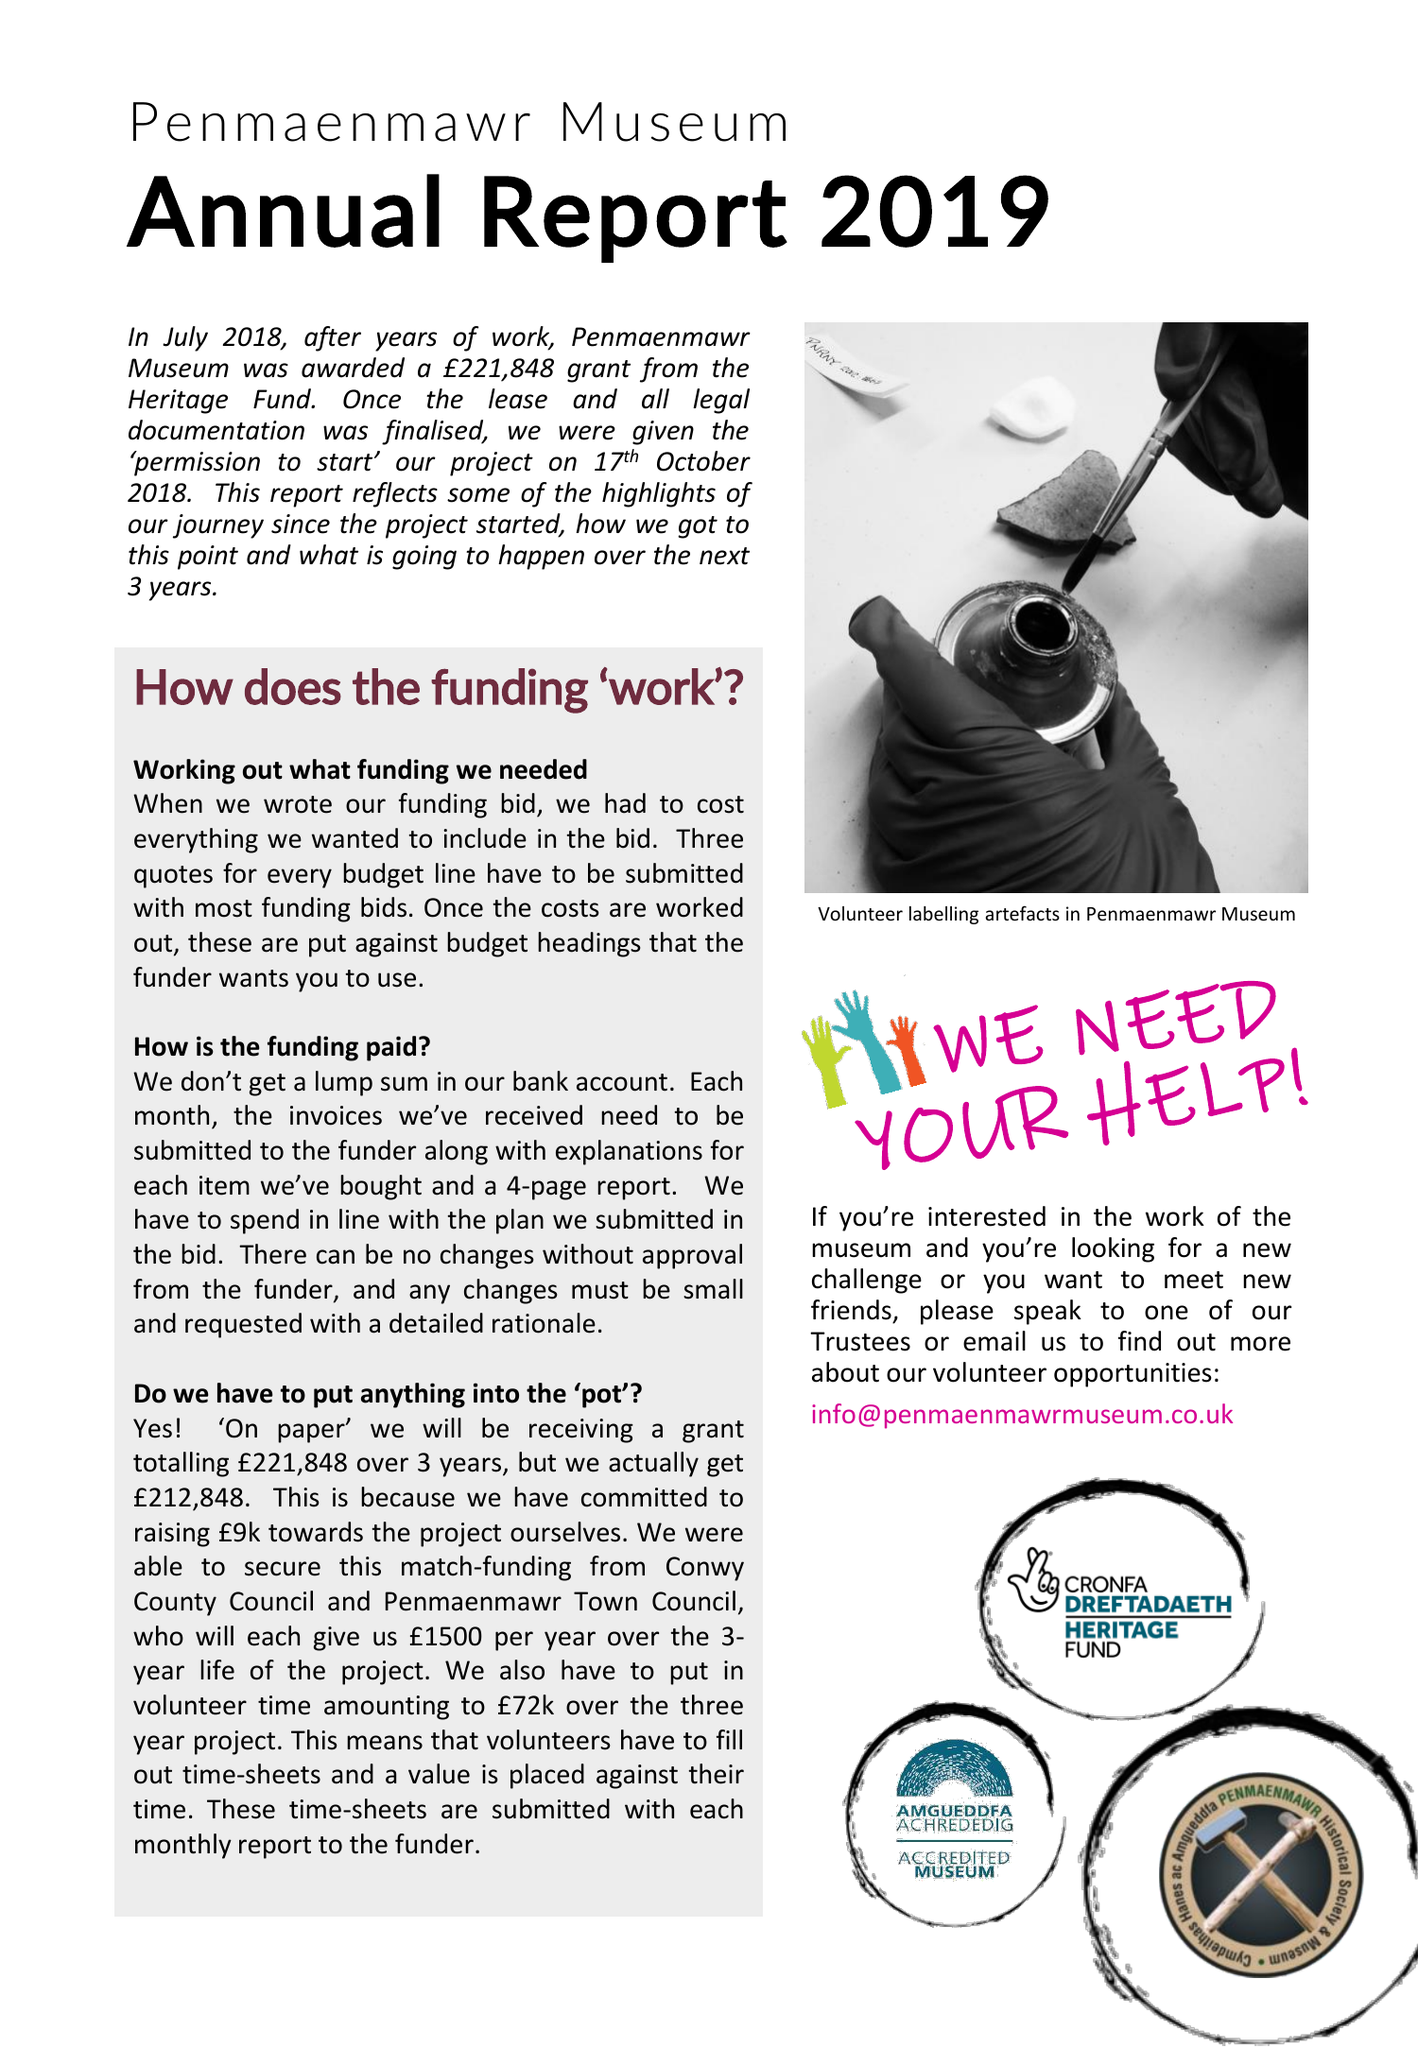What is the value for the spending_annually_in_british_pounds?
Answer the question using a single word or phrase. 73866.00 